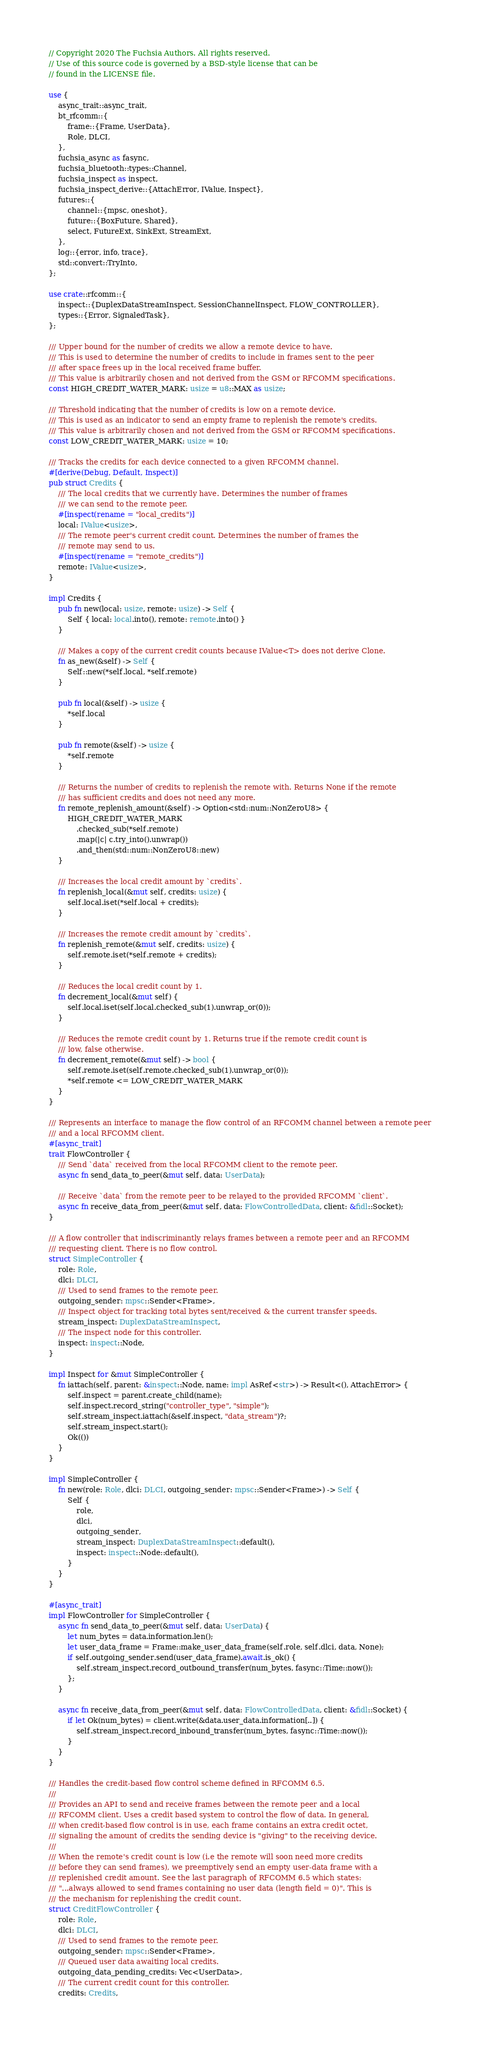Convert code to text. <code><loc_0><loc_0><loc_500><loc_500><_Rust_>// Copyright 2020 The Fuchsia Authors. All rights reserved.
// Use of this source code is governed by a BSD-style license that can be
// found in the LICENSE file.

use {
    async_trait::async_trait,
    bt_rfcomm::{
        frame::{Frame, UserData},
        Role, DLCI,
    },
    fuchsia_async as fasync,
    fuchsia_bluetooth::types::Channel,
    fuchsia_inspect as inspect,
    fuchsia_inspect_derive::{AttachError, IValue, Inspect},
    futures::{
        channel::{mpsc, oneshot},
        future::{BoxFuture, Shared},
        select, FutureExt, SinkExt, StreamExt,
    },
    log::{error, info, trace},
    std::convert::TryInto,
};

use crate::rfcomm::{
    inspect::{DuplexDataStreamInspect, SessionChannelInspect, FLOW_CONTROLLER},
    types::{Error, SignaledTask},
};

/// Upper bound for the number of credits we allow a remote device to have.
/// This is used to determine the number of credits to include in frames sent to the peer
/// after space frees up in the local received frame buffer.
/// This value is arbitrarily chosen and not derived from the GSM or RFCOMM specifications.
const HIGH_CREDIT_WATER_MARK: usize = u8::MAX as usize;

/// Threshold indicating that the number of credits is low on a remote device.
/// This is used as an indicator to send an empty frame to replenish the remote's credits.
/// This value is arbitrarily chosen and not derived from the GSM or RFCOMM specifications.
const LOW_CREDIT_WATER_MARK: usize = 10;

/// Tracks the credits for each device connected to a given RFCOMM channel.
#[derive(Debug, Default, Inspect)]
pub struct Credits {
    /// The local credits that we currently have. Determines the number of frames
    /// we can send to the remote peer.
    #[inspect(rename = "local_credits")]
    local: IValue<usize>,
    /// The remote peer's current credit count. Determines the number of frames the
    /// remote may send to us.
    #[inspect(rename = "remote_credits")]
    remote: IValue<usize>,
}

impl Credits {
    pub fn new(local: usize, remote: usize) -> Self {
        Self { local: local.into(), remote: remote.into() }
    }

    /// Makes a copy of the current credit counts because IValue<T> does not derive Clone.
    fn as_new(&self) -> Self {
        Self::new(*self.local, *self.remote)
    }

    pub fn local(&self) -> usize {
        *self.local
    }

    pub fn remote(&self) -> usize {
        *self.remote
    }

    /// Returns the number of credits to replenish the remote with. Returns None if the remote
    /// has sufficient credits and does not need any more.
    fn remote_replenish_amount(&self) -> Option<std::num::NonZeroU8> {
        HIGH_CREDIT_WATER_MARK
            .checked_sub(*self.remote)
            .map(|c| c.try_into().unwrap())
            .and_then(std::num::NonZeroU8::new)
    }

    /// Increases the local credit amount by `credits`.
    fn replenish_local(&mut self, credits: usize) {
        self.local.iset(*self.local + credits);
    }

    /// Increases the remote credit amount by `credits`.
    fn replenish_remote(&mut self, credits: usize) {
        self.remote.iset(*self.remote + credits);
    }

    /// Reduces the local credit count by 1.
    fn decrement_local(&mut self) {
        self.local.iset(self.local.checked_sub(1).unwrap_or(0));
    }

    /// Reduces the remote credit count by 1. Returns true if the remote credit count is
    /// low, false otherwise.
    fn decrement_remote(&mut self) -> bool {
        self.remote.iset(self.remote.checked_sub(1).unwrap_or(0));
        *self.remote <= LOW_CREDIT_WATER_MARK
    }
}

/// Represents an interface to manage the flow control of an RFCOMM channel between a remote peer
/// and a local RFCOMM client.
#[async_trait]
trait FlowController {
    /// Send `data` received from the local RFCOMM client to the remote peer.
    async fn send_data_to_peer(&mut self, data: UserData);

    /// Receive `data` from the remote peer to be relayed to the provided RFCOMM `client`.
    async fn receive_data_from_peer(&mut self, data: FlowControlledData, client: &fidl::Socket);
}

/// A flow controller that indiscriminantly relays frames between a remote peer and an RFCOMM
/// requesting client. There is no flow control.
struct SimpleController {
    role: Role,
    dlci: DLCI,
    /// Used to send frames to the remote peer.
    outgoing_sender: mpsc::Sender<Frame>,
    /// Inspect object for tracking total bytes sent/received & the current transfer speeds.
    stream_inspect: DuplexDataStreamInspect,
    /// The inspect node for this controller.
    inspect: inspect::Node,
}

impl Inspect for &mut SimpleController {
    fn iattach(self, parent: &inspect::Node, name: impl AsRef<str>) -> Result<(), AttachError> {
        self.inspect = parent.create_child(name);
        self.inspect.record_string("controller_type", "simple");
        self.stream_inspect.iattach(&self.inspect, "data_stream")?;
        self.stream_inspect.start();
        Ok(())
    }
}

impl SimpleController {
    fn new(role: Role, dlci: DLCI, outgoing_sender: mpsc::Sender<Frame>) -> Self {
        Self {
            role,
            dlci,
            outgoing_sender,
            stream_inspect: DuplexDataStreamInspect::default(),
            inspect: inspect::Node::default(),
        }
    }
}

#[async_trait]
impl FlowController for SimpleController {
    async fn send_data_to_peer(&mut self, data: UserData) {
        let num_bytes = data.information.len();
        let user_data_frame = Frame::make_user_data_frame(self.role, self.dlci, data, None);
        if self.outgoing_sender.send(user_data_frame).await.is_ok() {
            self.stream_inspect.record_outbound_transfer(num_bytes, fasync::Time::now());
        };
    }

    async fn receive_data_from_peer(&mut self, data: FlowControlledData, client: &fidl::Socket) {
        if let Ok(num_bytes) = client.write(&data.user_data.information[..]) {
            self.stream_inspect.record_inbound_transfer(num_bytes, fasync::Time::now());
        }
    }
}

/// Handles the credit-based flow control scheme defined in RFCOMM 6.5.
///
/// Provides an API to send and receive frames between the remote peer and a local
/// RFCOMM client. Uses a credit based system to control the flow of data. In general,
/// when credit-based flow control is in use, each frame contains an extra credit octet,
/// signaling the amount of credits the sending device is "giving" to the receiving device.
///
/// When the remote's credit count is low (i.e the remote will soon need more credits
/// before they can send frames), we preemptively send an empty user-data frame with a
/// replenished credit amount. See the last paragraph of RFCOMM 6.5 which states:
/// "...always allowed to send frames containing no user data (length field = 0)". This is
/// the mechanism for replenishing the credit count.
struct CreditFlowController {
    role: Role,
    dlci: DLCI,
    /// Used to send frames to the remote peer.
    outgoing_sender: mpsc::Sender<Frame>,
    /// Queued user data awaiting local credits.
    outgoing_data_pending_credits: Vec<UserData>,
    /// The current credit count for this controller.
    credits: Credits,</code> 